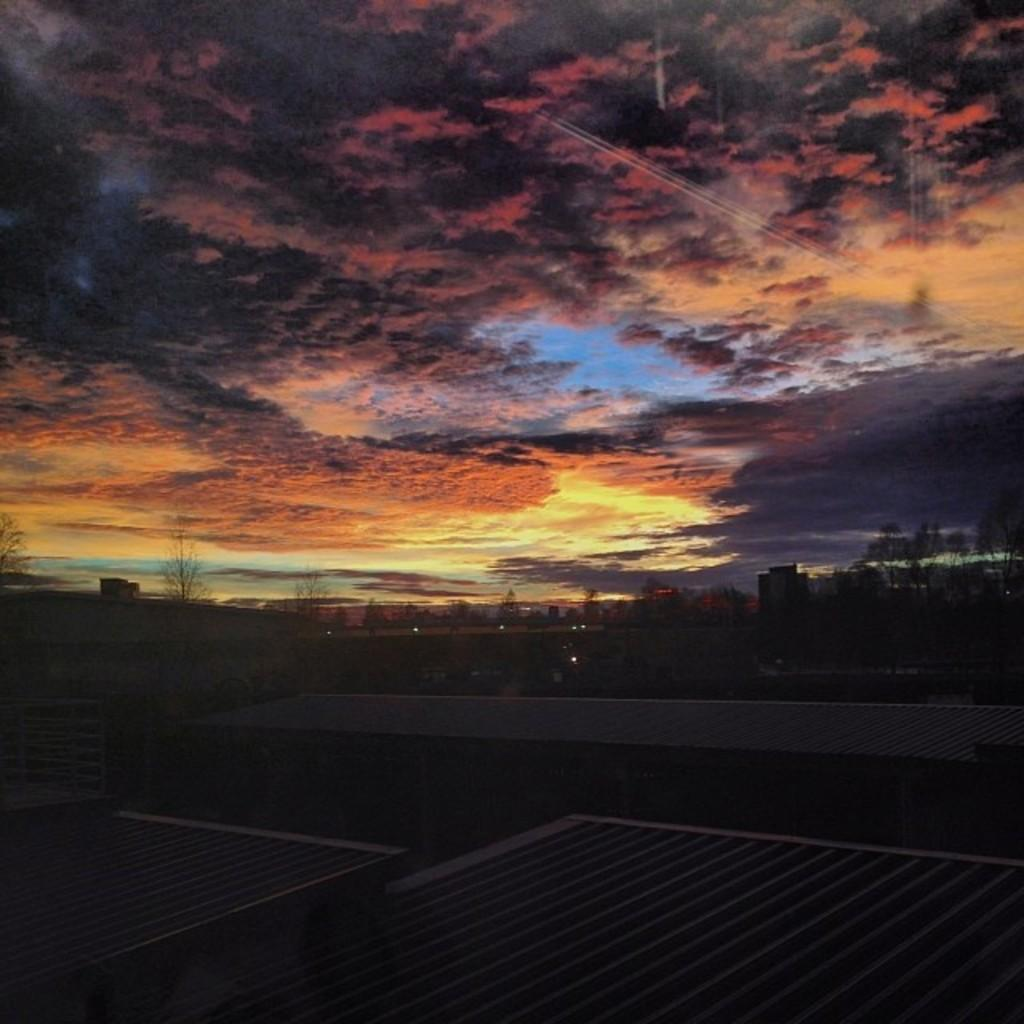What type of natural elements can be seen in the image? There are trees in the image. What type of man-made structures are present in the image? There are buildings in the image. What type of illumination is present in the image? There are lights in the image. What type of surface is visible in the image? There is a floor visible in the image. What type of atmospheric conditions can be seen in the image? There is sky visible in the image, and there are clouds present. What type of acoustics can be heard from the metal in the image? There is no metal present in the image, and therefore no acoustics can be heard from it. Can you see a plane flying in the sky in the image? There is no plane visible in the image; only trees, buildings, lights, floor, sky, and clouds are present. 